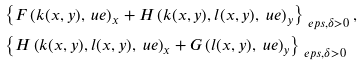<formula> <loc_0><loc_0><loc_500><loc_500>& \left \{ F \left ( k ( x , y ) , \ u e \right ) _ { x } + H \left ( k ( x , y ) , l ( x , y ) , \ u e \right ) _ { y } \right \} _ { \ e p s , \delta > 0 } , \\ & \left \{ H \left ( k ( x , y ) , l ( x , y ) , \ u e \right ) _ { x } + G \left ( l ( x , y ) , \ u e \right ) _ { y } \right \} _ { \ e p s , \delta > 0 }</formula> 